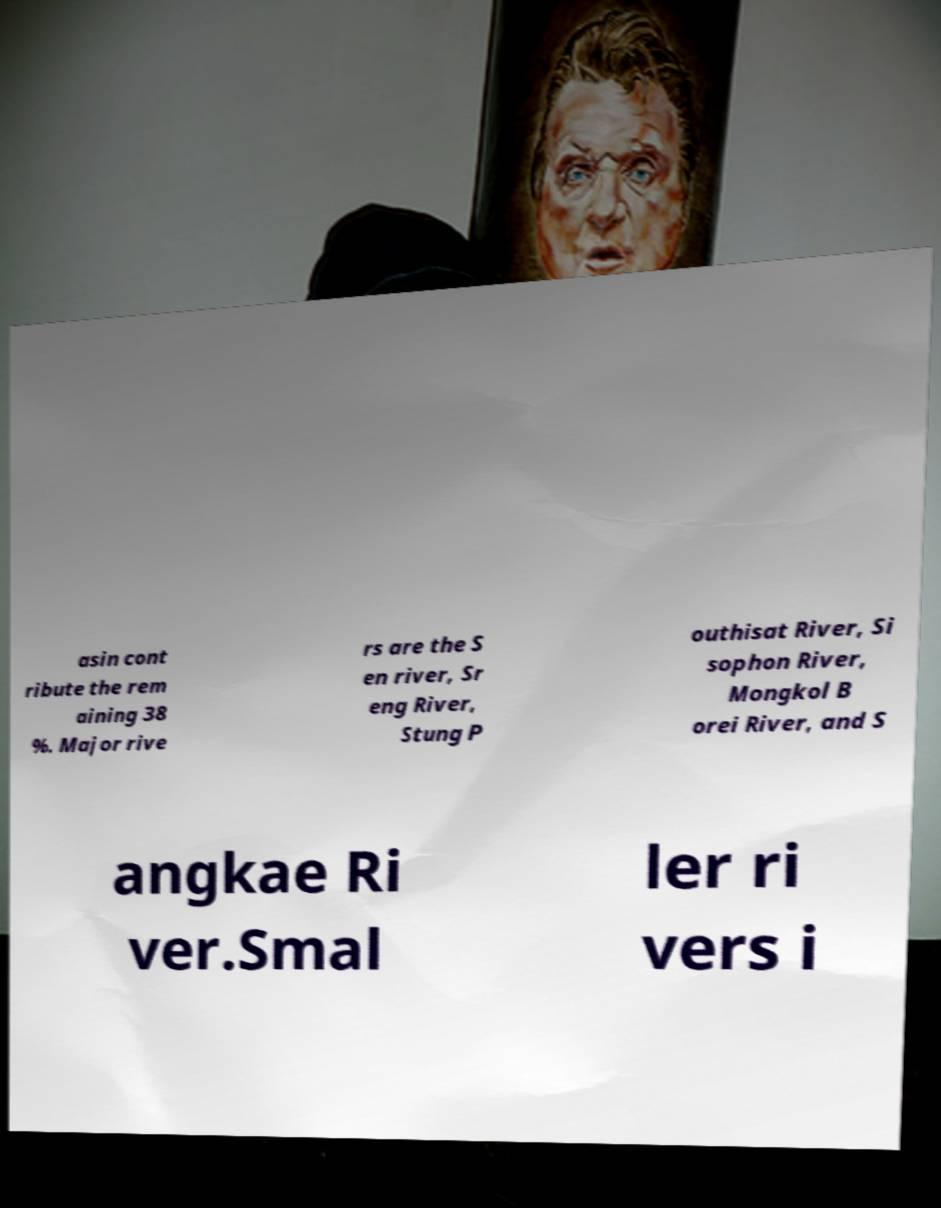Please read and relay the text visible in this image. What does it say? asin cont ribute the rem aining 38 %. Major rive rs are the S en river, Sr eng River, Stung P outhisat River, Si sophon River, Mongkol B orei River, and S angkae Ri ver.Smal ler ri vers i 